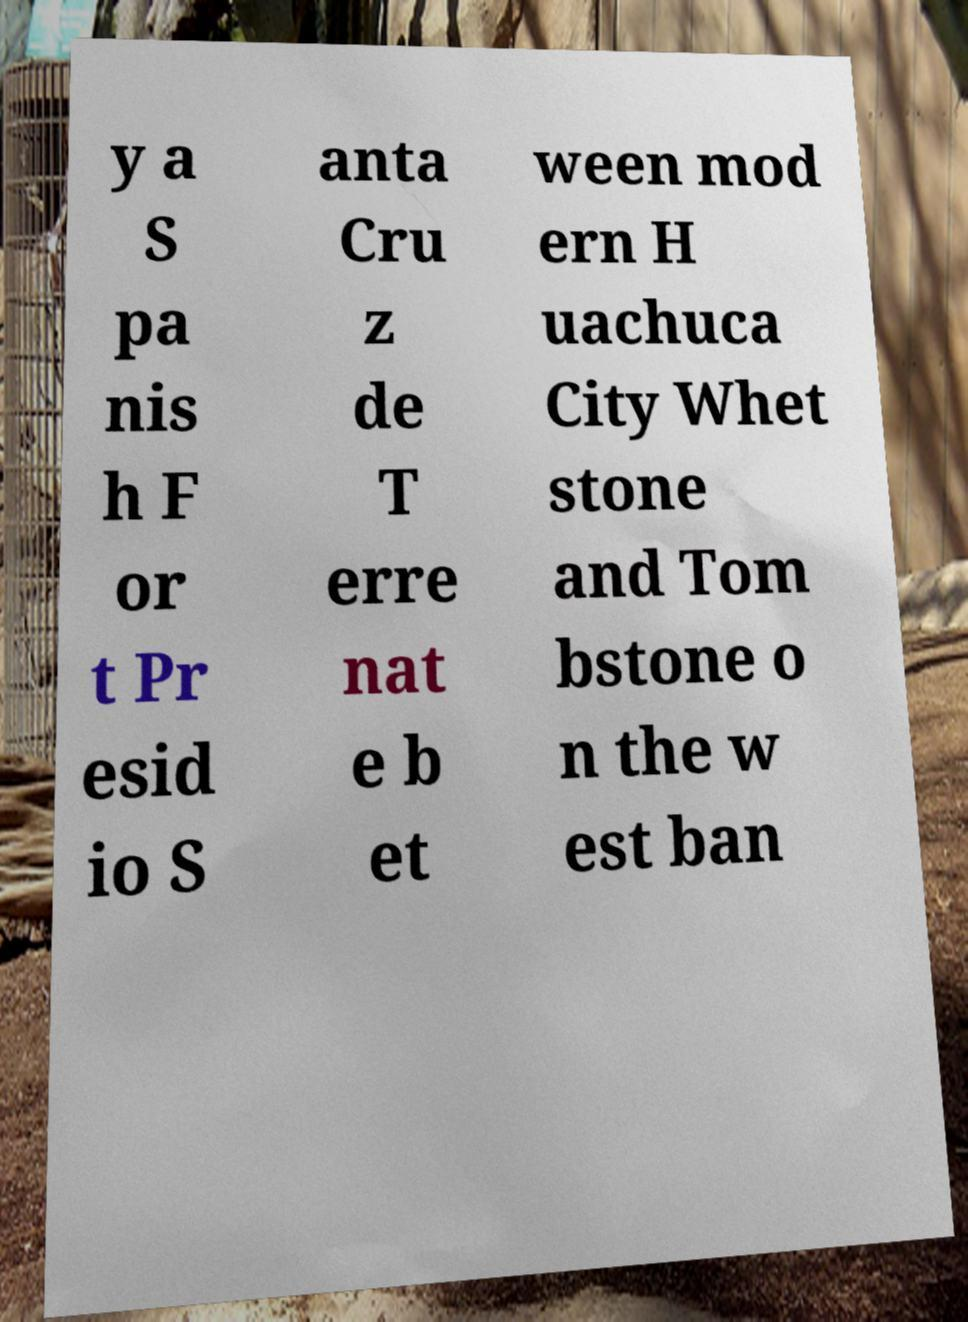There's text embedded in this image that I need extracted. Can you transcribe it verbatim? y a S pa nis h F or t Pr esid io S anta Cru z de T erre nat e b et ween mod ern H uachuca City Whet stone and Tom bstone o n the w est ban 